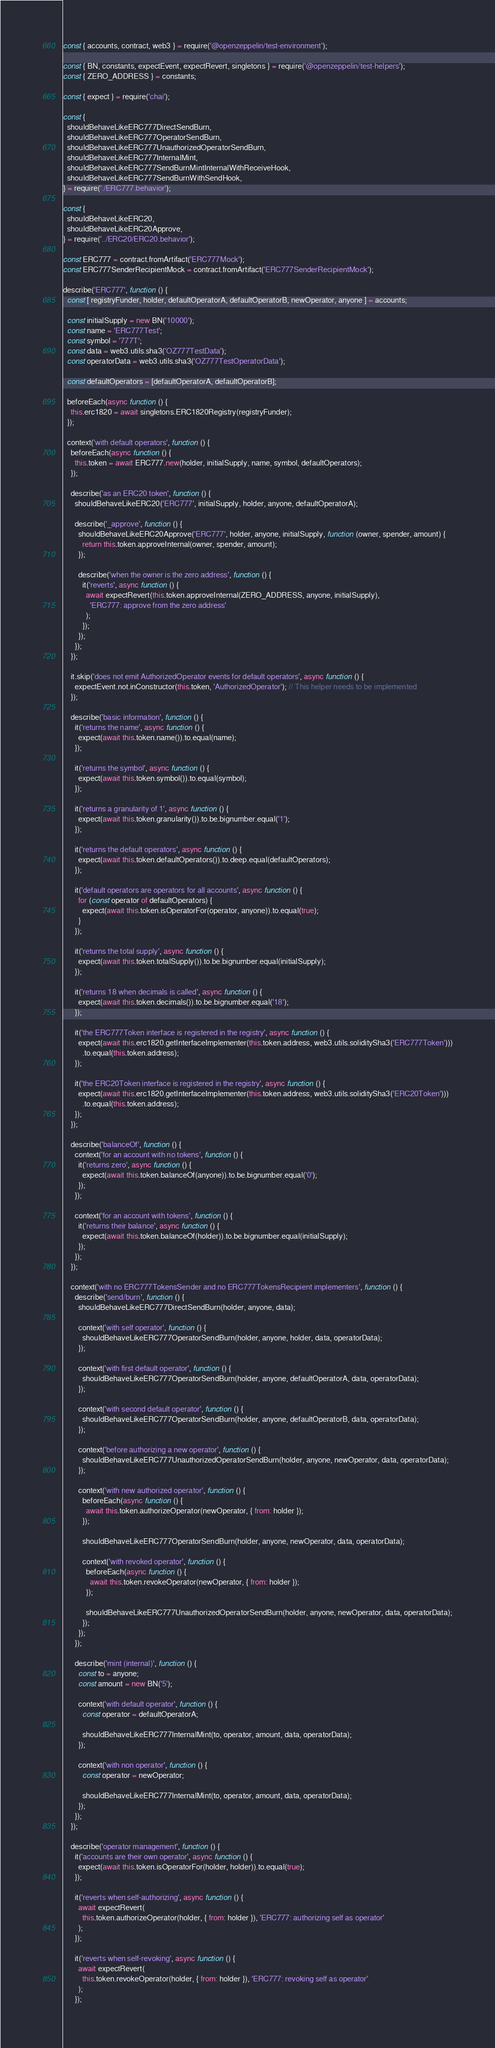Convert code to text. <code><loc_0><loc_0><loc_500><loc_500><_JavaScript_>const { accounts, contract, web3 } = require('@openzeppelin/test-environment');

const { BN, constants, expectEvent, expectRevert, singletons } = require('@openzeppelin/test-helpers');
const { ZERO_ADDRESS } = constants;

const { expect } = require('chai');

const {
  shouldBehaveLikeERC777DirectSendBurn,
  shouldBehaveLikeERC777OperatorSendBurn,
  shouldBehaveLikeERC777UnauthorizedOperatorSendBurn,
  shouldBehaveLikeERC777InternalMint,
  shouldBehaveLikeERC777SendBurnMintInternalWithReceiveHook,
  shouldBehaveLikeERC777SendBurnWithSendHook,
} = require('./ERC777.behavior');

const {
  shouldBehaveLikeERC20,
  shouldBehaveLikeERC20Approve,
} = require('../ERC20/ERC20.behavior');

const ERC777 = contract.fromArtifact('ERC777Mock');
const ERC777SenderRecipientMock = contract.fromArtifact('ERC777SenderRecipientMock');

describe('ERC777', function () {
  const [ registryFunder, holder, defaultOperatorA, defaultOperatorB, newOperator, anyone ] = accounts;

  const initialSupply = new BN('10000');
  const name = 'ERC777Test';
  const symbol = '777T';
  const data = web3.utils.sha3('OZ777TestData');
  const operatorData = web3.utils.sha3('OZ777TestOperatorData');

  const defaultOperators = [defaultOperatorA, defaultOperatorB];

  beforeEach(async function () {
    this.erc1820 = await singletons.ERC1820Registry(registryFunder);
  });

  context('with default operators', function () {
    beforeEach(async function () {
      this.token = await ERC777.new(holder, initialSupply, name, symbol, defaultOperators);
    });

    describe('as an ERC20 token', function () {
      shouldBehaveLikeERC20('ERC777', initialSupply, holder, anyone, defaultOperatorA);

      describe('_approve', function () {
        shouldBehaveLikeERC20Approve('ERC777', holder, anyone, initialSupply, function (owner, spender, amount) {
          return this.token.approveInternal(owner, spender, amount);
        });

        describe('when the owner is the zero address', function () {
          it('reverts', async function () {
            await expectRevert(this.token.approveInternal(ZERO_ADDRESS, anyone, initialSupply),
              'ERC777: approve from the zero address'
            );
          });
        });
      });
    });

    it.skip('does not emit AuthorizedOperator events for default operators', async function () {
      expectEvent.not.inConstructor(this.token, 'AuthorizedOperator'); // This helper needs to be implemented
    });

    describe('basic information', function () {
      it('returns the name', async function () {
        expect(await this.token.name()).to.equal(name);
      });

      it('returns the symbol', async function () {
        expect(await this.token.symbol()).to.equal(symbol);
      });

      it('returns a granularity of 1', async function () {
        expect(await this.token.granularity()).to.be.bignumber.equal('1');
      });

      it('returns the default operators', async function () {
        expect(await this.token.defaultOperators()).to.deep.equal(defaultOperators);
      });

      it('default operators are operators for all accounts', async function () {
        for (const operator of defaultOperators) {
          expect(await this.token.isOperatorFor(operator, anyone)).to.equal(true);
        }
      });

      it('returns the total supply', async function () {
        expect(await this.token.totalSupply()).to.be.bignumber.equal(initialSupply);
      });

      it('returns 18 when decimals is called', async function () {
        expect(await this.token.decimals()).to.be.bignumber.equal('18');
      });

      it('the ERC777Token interface is registered in the registry', async function () {
        expect(await this.erc1820.getInterfaceImplementer(this.token.address, web3.utils.soliditySha3('ERC777Token')))
          .to.equal(this.token.address);
      });

      it('the ERC20Token interface is registered in the registry', async function () {
        expect(await this.erc1820.getInterfaceImplementer(this.token.address, web3.utils.soliditySha3('ERC20Token')))
          .to.equal(this.token.address);
      });
    });

    describe('balanceOf', function () {
      context('for an account with no tokens', function () {
        it('returns zero', async function () {
          expect(await this.token.balanceOf(anyone)).to.be.bignumber.equal('0');
        });
      });

      context('for an account with tokens', function () {
        it('returns their balance', async function () {
          expect(await this.token.balanceOf(holder)).to.be.bignumber.equal(initialSupply);
        });
      });
    });

    context('with no ERC777TokensSender and no ERC777TokensRecipient implementers', function () {
      describe('send/burn', function () {
        shouldBehaveLikeERC777DirectSendBurn(holder, anyone, data);

        context('with self operator', function () {
          shouldBehaveLikeERC777OperatorSendBurn(holder, anyone, holder, data, operatorData);
        });

        context('with first default operator', function () {
          shouldBehaveLikeERC777OperatorSendBurn(holder, anyone, defaultOperatorA, data, operatorData);
        });

        context('with second default operator', function () {
          shouldBehaveLikeERC777OperatorSendBurn(holder, anyone, defaultOperatorB, data, operatorData);
        });

        context('before authorizing a new operator', function () {
          shouldBehaveLikeERC777UnauthorizedOperatorSendBurn(holder, anyone, newOperator, data, operatorData);
        });

        context('with new authorized operator', function () {
          beforeEach(async function () {
            await this.token.authorizeOperator(newOperator, { from: holder });
          });

          shouldBehaveLikeERC777OperatorSendBurn(holder, anyone, newOperator, data, operatorData);

          context('with revoked operator', function () {
            beforeEach(async function () {
              await this.token.revokeOperator(newOperator, { from: holder });
            });

            shouldBehaveLikeERC777UnauthorizedOperatorSendBurn(holder, anyone, newOperator, data, operatorData);
          });
        });
      });

      describe('mint (internal)', function () {
        const to = anyone;
        const amount = new BN('5');

        context('with default operator', function () {
          const operator = defaultOperatorA;

          shouldBehaveLikeERC777InternalMint(to, operator, amount, data, operatorData);
        });

        context('with non operator', function () {
          const operator = newOperator;

          shouldBehaveLikeERC777InternalMint(to, operator, amount, data, operatorData);
        });
      });
    });

    describe('operator management', function () {
      it('accounts are their own operator', async function () {
        expect(await this.token.isOperatorFor(holder, holder)).to.equal(true);
      });

      it('reverts when self-authorizing', async function () {
        await expectRevert(
          this.token.authorizeOperator(holder, { from: holder }), 'ERC777: authorizing self as operator'
        );
      });

      it('reverts when self-revoking', async function () {
        await expectRevert(
          this.token.revokeOperator(holder, { from: holder }), 'ERC777: revoking self as operator'
        );
      });
</code> 